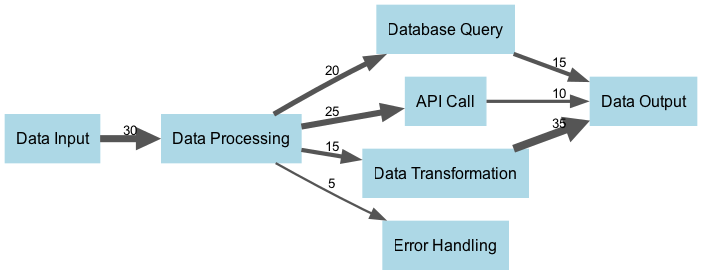What is the total processing time allocated to Data Processing? The total processing time allocated to Data Processing can be found by looking at the value directly associated with the node itself, which is the sum of all its outgoing links. We see that Data Processing has three outgoing links (to Database Query, API Call, and Data Transformation), which sum up to 20 + 25 + 15 = 60. Therefore, the total allocated time for Data Processing is 30.
Answer: 30 How many nodes are present in the diagram? To find the number of nodes, we simply count how many unique nodes are listed in the data. According to the provided data, the nodes are Data Input, Data Processing, Database Query, API Call, Data Transformation, Data Output, and Error Handling. That's a total of 7 nodes.
Answer: 7 What is the value of the link from Data Processing to Error Handling? The value of the link from Data Processing to Error Handling can be found by examining the outgoing links from the Data Processing node in the provided data. One of the links listed is specifically from Data Processing to Error Handling with a value of 5.
Answer: 5 Which node receives the highest processing time? To determine which node receives the highest processing time, we look at the total incoming link values for each node. By checking each link, we see that Data Output receives values from three sources: Data Transformation (35), Database Query (15), and API Call (10). The total incoming value for Data Output is therefore 35 + 15 + 10 = 60. This is higher than any other node, making Data Output the node with the highest processing time.
Answer: Data Output What is the total processing time directed to Data Output? We can calculate the total processing time directed to Data Output by adding all incoming link values. Reviewing the incoming links, we have Data Transformation contributing 35, Database Query contributing 15, and API Call contributing 10. Adding these values gives us 35 + 15 + 10 = 60. Hence, the total processing time directed to Data Output is 60.
Answer: 60 